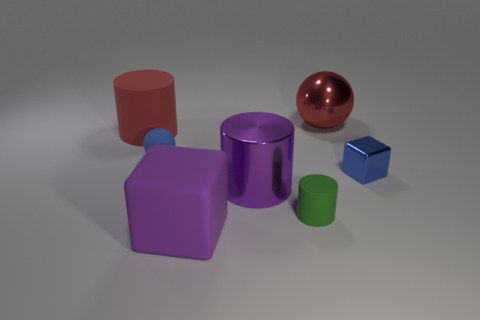Add 3 small red shiny cylinders. How many objects exist? 10 Subtract all cylinders. How many objects are left? 4 Subtract 1 blue blocks. How many objects are left? 6 Subtract all big cylinders. Subtract all purple metallic objects. How many objects are left? 4 Add 6 small blue balls. How many small blue balls are left? 7 Add 7 purple objects. How many purple objects exist? 9 